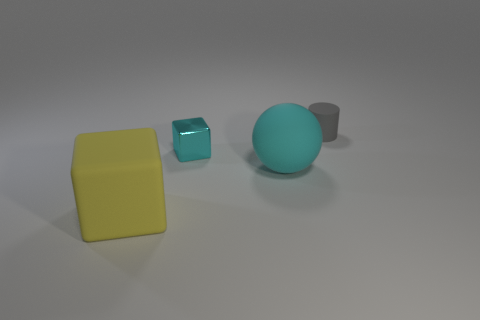Is there anything else that is the same material as the tiny cyan thing?
Give a very brief answer. No. Are there an equal number of cyan things that are to the left of the ball and yellow rubber objects that are in front of the yellow block?
Provide a succinct answer. No. Do the small object right of the big matte sphere and the big thing that is right of the big yellow matte block have the same color?
Provide a short and direct response. No. Are there more gray rubber things behind the tiny rubber object than gray matte cylinders?
Your response must be concise. No. There is a big yellow thing that is made of the same material as the gray thing; what is its shape?
Offer a very short reply. Cube. There is a cube to the right of the yellow cube; is it the same size as the gray rubber thing?
Your answer should be very brief. Yes. There is a big matte thing that is on the right side of the small object on the left side of the big rubber sphere; what shape is it?
Give a very brief answer. Sphere. There is a object that is behind the tiny object in front of the gray matte cylinder; how big is it?
Offer a terse response. Small. There is a tiny thing that is to the left of the gray rubber object; what color is it?
Make the answer very short. Cyan. There is a cube that is the same material as the gray cylinder; what size is it?
Make the answer very short. Large. 